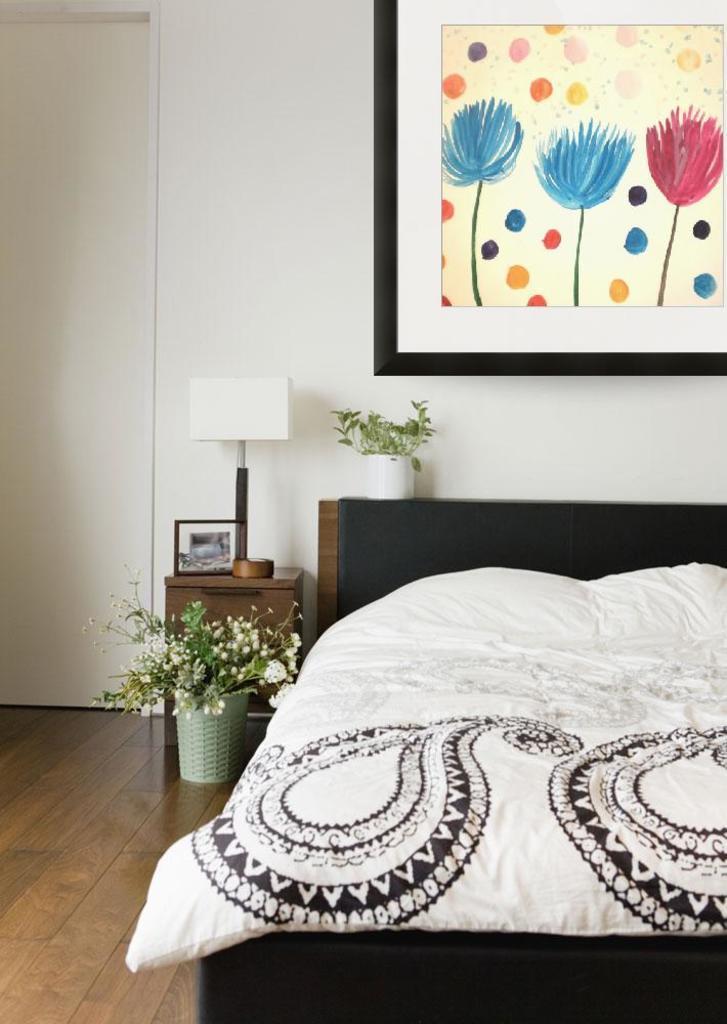In one or two sentences, can you explain what this image depicts? In this picture we can see a bed, this is the floor. And there is a plant. And on the wall there is a frame with flowers. This is the table, there is a lamp. And this is the frame on the table. 